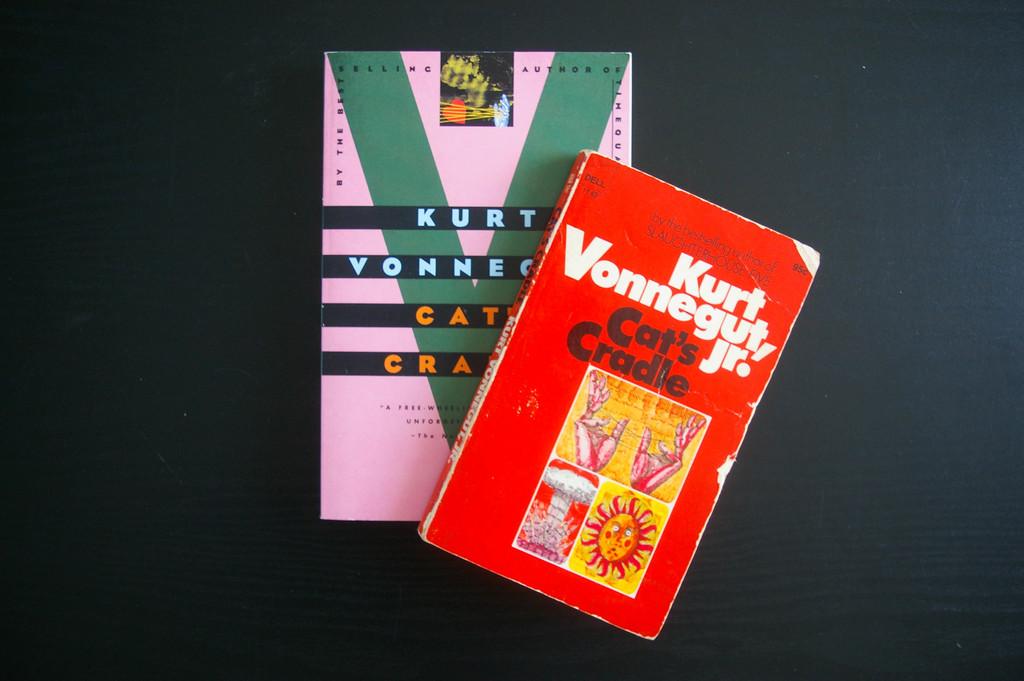Who wrote these books?
Your answer should be compact. Kurt vonnegut jr. 